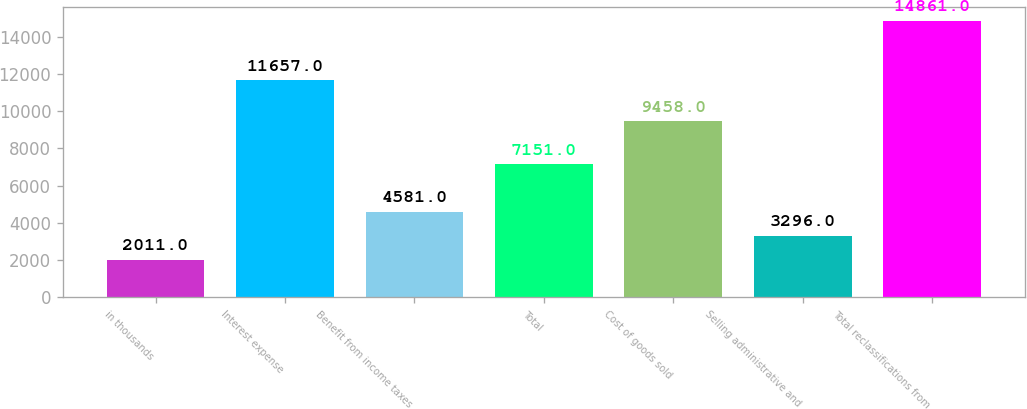<chart> <loc_0><loc_0><loc_500><loc_500><bar_chart><fcel>in thousands<fcel>Interest expense<fcel>Benefit from income taxes<fcel>Total<fcel>Cost of goods sold<fcel>Selling administrative and<fcel>Total reclassifications from<nl><fcel>2011<fcel>11657<fcel>4581<fcel>7151<fcel>9458<fcel>3296<fcel>14861<nl></chart> 